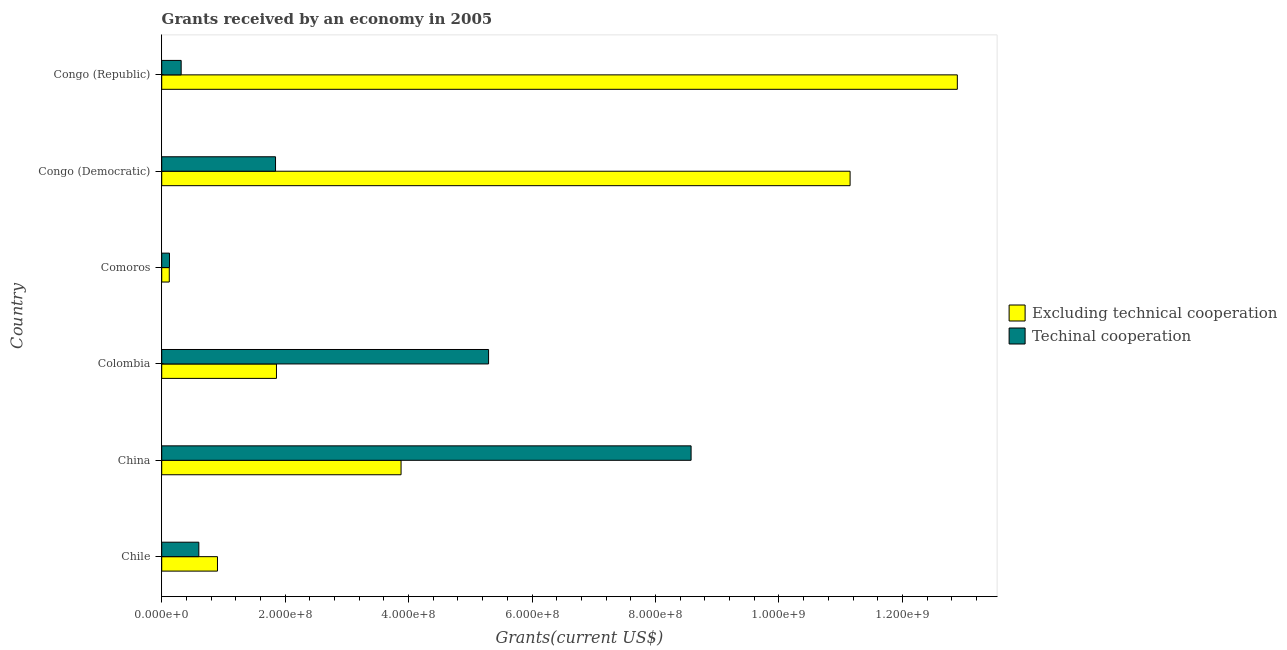How many different coloured bars are there?
Your answer should be very brief. 2. How many groups of bars are there?
Your answer should be very brief. 6. Are the number of bars per tick equal to the number of legend labels?
Your answer should be very brief. Yes. What is the label of the 6th group of bars from the top?
Your answer should be very brief. Chile. In how many cases, is the number of bars for a given country not equal to the number of legend labels?
Provide a short and direct response. 0. What is the amount of grants received(excluding technical cooperation) in Congo (Democratic)?
Your response must be concise. 1.12e+09. Across all countries, what is the maximum amount of grants received(including technical cooperation)?
Provide a short and direct response. 8.58e+08. Across all countries, what is the minimum amount of grants received(including technical cooperation)?
Provide a succinct answer. 1.26e+07. In which country was the amount of grants received(excluding technical cooperation) maximum?
Your response must be concise. Congo (Republic). In which country was the amount of grants received(including technical cooperation) minimum?
Make the answer very short. Comoros. What is the total amount of grants received(including technical cooperation) in the graph?
Make the answer very short. 1.68e+09. What is the difference between the amount of grants received(excluding technical cooperation) in China and that in Colombia?
Your answer should be very brief. 2.02e+08. What is the difference between the amount of grants received(including technical cooperation) in China and the amount of grants received(excluding technical cooperation) in Congo (Democratic)?
Give a very brief answer. -2.58e+08. What is the average amount of grants received(including technical cooperation) per country?
Give a very brief answer. 2.79e+08. What is the difference between the amount of grants received(including technical cooperation) and amount of grants received(excluding technical cooperation) in Comoros?
Your response must be concise. 3.30e+05. In how many countries, is the amount of grants received(excluding technical cooperation) greater than 560000000 US$?
Offer a very short reply. 2. What is the ratio of the amount of grants received(including technical cooperation) in China to that in Comoros?
Your answer should be compact. 68.07. Is the amount of grants received(excluding technical cooperation) in Chile less than that in Colombia?
Your answer should be very brief. Yes. What is the difference between the highest and the second highest amount of grants received(excluding technical cooperation)?
Provide a short and direct response. 1.74e+08. What is the difference between the highest and the lowest amount of grants received(including technical cooperation)?
Give a very brief answer. 8.45e+08. In how many countries, is the amount of grants received(excluding technical cooperation) greater than the average amount of grants received(excluding technical cooperation) taken over all countries?
Make the answer very short. 2. What does the 2nd bar from the top in Congo (Democratic) represents?
Give a very brief answer. Excluding technical cooperation. What does the 1st bar from the bottom in Colombia represents?
Offer a terse response. Excluding technical cooperation. Are all the bars in the graph horizontal?
Make the answer very short. Yes. How many countries are there in the graph?
Your response must be concise. 6. What is the difference between two consecutive major ticks on the X-axis?
Provide a short and direct response. 2.00e+08. How many legend labels are there?
Provide a short and direct response. 2. What is the title of the graph?
Your answer should be very brief. Grants received by an economy in 2005. Does "Urban" appear as one of the legend labels in the graph?
Keep it short and to the point. No. What is the label or title of the X-axis?
Your answer should be compact. Grants(current US$). What is the label or title of the Y-axis?
Offer a very short reply. Country. What is the Grants(current US$) in Excluding technical cooperation in Chile?
Your answer should be very brief. 9.03e+07. What is the Grants(current US$) in Techinal cooperation in Chile?
Provide a succinct answer. 6.01e+07. What is the Grants(current US$) in Excluding technical cooperation in China?
Provide a succinct answer. 3.88e+08. What is the Grants(current US$) of Techinal cooperation in China?
Your response must be concise. 8.58e+08. What is the Grants(current US$) in Excluding technical cooperation in Colombia?
Offer a terse response. 1.86e+08. What is the Grants(current US$) in Techinal cooperation in Colombia?
Your response must be concise. 5.30e+08. What is the Grants(current US$) in Excluding technical cooperation in Comoros?
Your answer should be very brief. 1.23e+07. What is the Grants(current US$) in Techinal cooperation in Comoros?
Provide a succinct answer. 1.26e+07. What is the Grants(current US$) of Excluding technical cooperation in Congo (Democratic)?
Give a very brief answer. 1.12e+09. What is the Grants(current US$) in Techinal cooperation in Congo (Democratic)?
Your answer should be compact. 1.84e+08. What is the Grants(current US$) of Excluding technical cooperation in Congo (Republic)?
Offer a very short reply. 1.29e+09. What is the Grants(current US$) in Techinal cooperation in Congo (Republic)?
Provide a short and direct response. 3.15e+07. Across all countries, what is the maximum Grants(current US$) of Excluding technical cooperation?
Offer a very short reply. 1.29e+09. Across all countries, what is the maximum Grants(current US$) of Techinal cooperation?
Ensure brevity in your answer.  8.58e+08. Across all countries, what is the minimum Grants(current US$) of Excluding technical cooperation?
Offer a very short reply. 1.23e+07. Across all countries, what is the minimum Grants(current US$) in Techinal cooperation?
Offer a very short reply. 1.26e+07. What is the total Grants(current US$) in Excluding technical cooperation in the graph?
Give a very brief answer. 3.08e+09. What is the total Grants(current US$) of Techinal cooperation in the graph?
Provide a succinct answer. 1.68e+09. What is the difference between the Grants(current US$) in Excluding technical cooperation in Chile and that in China?
Make the answer very short. -2.97e+08. What is the difference between the Grants(current US$) of Techinal cooperation in Chile and that in China?
Keep it short and to the point. -7.98e+08. What is the difference between the Grants(current US$) of Excluding technical cooperation in Chile and that in Colombia?
Your answer should be very brief. -9.56e+07. What is the difference between the Grants(current US$) of Techinal cooperation in Chile and that in Colombia?
Make the answer very short. -4.69e+08. What is the difference between the Grants(current US$) of Excluding technical cooperation in Chile and that in Comoros?
Provide a short and direct response. 7.81e+07. What is the difference between the Grants(current US$) of Techinal cooperation in Chile and that in Comoros?
Make the answer very short. 4.75e+07. What is the difference between the Grants(current US$) of Excluding technical cooperation in Chile and that in Congo (Democratic)?
Your answer should be compact. -1.02e+09. What is the difference between the Grants(current US$) of Techinal cooperation in Chile and that in Congo (Democratic)?
Ensure brevity in your answer.  -1.24e+08. What is the difference between the Grants(current US$) in Excluding technical cooperation in Chile and that in Congo (Republic)?
Ensure brevity in your answer.  -1.20e+09. What is the difference between the Grants(current US$) of Techinal cooperation in Chile and that in Congo (Republic)?
Give a very brief answer. 2.86e+07. What is the difference between the Grants(current US$) of Excluding technical cooperation in China and that in Colombia?
Give a very brief answer. 2.02e+08. What is the difference between the Grants(current US$) in Techinal cooperation in China and that in Colombia?
Make the answer very short. 3.28e+08. What is the difference between the Grants(current US$) of Excluding technical cooperation in China and that in Comoros?
Keep it short and to the point. 3.76e+08. What is the difference between the Grants(current US$) of Techinal cooperation in China and that in Comoros?
Give a very brief answer. 8.45e+08. What is the difference between the Grants(current US$) of Excluding technical cooperation in China and that in Congo (Democratic)?
Keep it short and to the point. -7.27e+08. What is the difference between the Grants(current US$) of Techinal cooperation in China and that in Congo (Democratic)?
Give a very brief answer. 6.73e+08. What is the difference between the Grants(current US$) in Excluding technical cooperation in China and that in Congo (Republic)?
Provide a succinct answer. -9.01e+08. What is the difference between the Grants(current US$) in Techinal cooperation in China and that in Congo (Republic)?
Offer a terse response. 8.26e+08. What is the difference between the Grants(current US$) in Excluding technical cooperation in Colombia and that in Comoros?
Your answer should be compact. 1.74e+08. What is the difference between the Grants(current US$) in Techinal cooperation in Colombia and that in Comoros?
Provide a succinct answer. 5.17e+08. What is the difference between the Grants(current US$) of Excluding technical cooperation in Colombia and that in Congo (Democratic)?
Keep it short and to the point. -9.29e+08. What is the difference between the Grants(current US$) of Techinal cooperation in Colombia and that in Congo (Democratic)?
Give a very brief answer. 3.45e+08. What is the difference between the Grants(current US$) in Excluding technical cooperation in Colombia and that in Congo (Republic)?
Your answer should be very brief. -1.10e+09. What is the difference between the Grants(current US$) in Techinal cooperation in Colombia and that in Congo (Republic)?
Give a very brief answer. 4.98e+08. What is the difference between the Grants(current US$) of Excluding technical cooperation in Comoros and that in Congo (Democratic)?
Your answer should be very brief. -1.10e+09. What is the difference between the Grants(current US$) in Techinal cooperation in Comoros and that in Congo (Democratic)?
Your response must be concise. -1.72e+08. What is the difference between the Grants(current US$) of Excluding technical cooperation in Comoros and that in Congo (Republic)?
Provide a short and direct response. -1.28e+09. What is the difference between the Grants(current US$) of Techinal cooperation in Comoros and that in Congo (Republic)?
Offer a terse response. -1.89e+07. What is the difference between the Grants(current US$) of Excluding technical cooperation in Congo (Democratic) and that in Congo (Republic)?
Give a very brief answer. -1.74e+08. What is the difference between the Grants(current US$) of Techinal cooperation in Congo (Democratic) and that in Congo (Republic)?
Offer a very short reply. 1.53e+08. What is the difference between the Grants(current US$) of Excluding technical cooperation in Chile and the Grants(current US$) of Techinal cooperation in China?
Your answer should be compact. -7.67e+08. What is the difference between the Grants(current US$) of Excluding technical cooperation in Chile and the Grants(current US$) of Techinal cooperation in Colombia?
Your answer should be compact. -4.39e+08. What is the difference between the Grants(current US$) of Excluding technical cooperation in Chile and the Grants(current US$) of Techinal cooperation in Comoros?
Your answer should be compact. 7.77e+07. What is the difference between the Grants(current US$) in Excluding technical cooperation in Chile and the Grants(current US$) in Techinal cooperation in Congo (Democratic)?
Ensure brevity in your answer.  -9.41e+07. What is the difference between the Grants(current US$) of Excluding technical cooperation in Chile and the Grants(current US$) of Techinal cooperation in Congo (Republic)?
Your response must be concise. 5.88e+07. What is the difference between the Grants(current US$) of Excluding technical cooperation in China and the Grants(current US$) of Techinal cooperation in Colombia?
Ensure brevity in your answer.  -1.42e+08. What is the difference between the Grants(current US$) of Excluding technical cooperation in China and the Grants(current US$) of Techinal cooperation in Comoros?
Offer a terse response. 3.75e+08. What is the difference between the Grants(current US$) of Excluding technical cooperation in China and the Grants(current US$) of Techinal cooperation in Congo (Democratic)?
Your answer should be compact. 2.03e+08. What is the difference between the Grants(current US$) in Excluding technical cooperation in China and the Grants(current US$) in Techinal cooperation in Congo (Republic)?
Your answer should be very brief. 3.56e+08. What is the difference between the Grants(current US$) of Excluding technical cooperation in Colombia and the Grants(current US$) of Techinal cooperation in Comoros?
Give a very brief answer. 1.73e+08. What is the difference between the Grants(current US$) of Excluding technical cooperation in Colombia and the Grants(current US$) of Techinal cooperation in Congo (Democratic)?
Keep it short and to the point. 1.52e+06. What is the difference between the Grants(current US$) in Excluding technical cooperation in Colombia and the Grants(current US$) in Techinal cooperation in Congo (Republic)?
Make the answer very short. 1.54e+08. What is the difference between the Grants(current US$) of Excluding technical cooperation in Comoros and the Grants(current US$) of Techinal cooperation in Congo (Democratic)?
Make the answer very short. -1.72e+08. What is the difference between the Grants(current US$) of Excluding technical cooperation in Comoros and the Grants(current US$) of Techinal cooperation in Congo (Republic)?
Your answer should be compact. -1.92e+07. What is the difference between the Grants(current US$) in Excluding technical cooperation in Congo (Democratic) and the Grants(current US$) in Techinal cooperation in Congo (Republic)?
Ensure brevity in your answer.  1.08e+09. What is the average Grants(current US$) of Excluding technical cooperation per country?
Give a very brief answer. 5.13e+08. What is the average Grants(current US$) in Techinal cooperation per country?
Offer a very short reply. 2.79e+08. What is the difference between the Grants(current US$) in Excluding technical cooperation and Grants(current US$) in Techinal cooperation in Chile?
Keep it short and to the point. 3.02e+07. What is the difference between the Grants(current US$) in Excluding technical cooperation and Grants(current US$) in Techinal cooperation in China?
Keep it short and to the point. -4.70e+08. What is the difference between the Grants(current US$) of Excluding technical cooperation and Grants(current US$) of Techinal cooperation in Colombia?
Your answer should be compact. -3.44e+08. What is the difference between the Grants(current US$) of Excluding technical cooperation and Grants(current US$) of Techinal cooperation in Comoros?
Provide a succinct answer. -3.30e+05. What is the difference between the Grants(current US$) of Excluding technical cooperation and Grants(current US$) of Techinal cooperation in Congo (Democratic)?
Your answer should be very brief. 9.31e+08. What is the difference between the Grants(current US$) of Excluding technical cooperation and Grants(current US$) of Techinal cooperation in Congo (Republic)?
Your answer should be very brief. 1.26e+09. What is the ratio of the Grants(current US$) of Excluding technical cooperation in Chile to that in China?
Your answer should be compact. 0.23. What is the ratio of the Grants(current US$) in Techinal cooperation in Chile to that in China?
Your answer should be very brief. 0.07. What is the ratio of the Grants(current US$) of Excluding technical cooperation in Chile to that in Colombia?
Your answer should be compact. 0.49. What is the ratio of the Grants(current US$) in Techinal cooperation in Chile to that in Colombia?
Provide a succinct answer. 0.11. What is the ratio of the Grants(current US$) of Excluding technical cooperation in Chile to that in Comoros?
Give a very brief answer. 7.36. What is the ratio of the Grants(current US$) in Techinal cooperation in Chile to that in Comoros?
Your answer should be very brief. 4.77. What is the ratio of the Grants(current US$) of Excluding technical cooperation in Chile to that in Congo (Democratic)?
Make the answer very short. 0.08. What is the ratio of the Grants(current US$) in Techinal cooperation in Chile to that in Congo (Democratic)?
Provide a succinct answer. 0.33. What is the ratio of the Grants(current US$) in Excluding technical cooperation in Chile to that in Congo (Republic)?
Provide a succinct answer. 0.07. What is the ratio of the Grants(current US$) of Techinal cooperation in Chile to that in Congo (Republic)?
Provide a succinct answer. 1.91. What is the ratio of the Grants(current US$) of Excluding technical cooperation in China to that in Colombia?
Keep it short and to the point. 2.09. What is the ratio of the Grants(current US$) in Techinal cooperation in China to that in Colombia?
Provide a succinct answer. 1.62. What is the ratio of the Grants(current US$) in Excluding technical cooperation in China to that in Comoros?
Offer a very short reply. 31.6. What is the ratio of the Grants(current US$) of Techinal cooperation in China to that in Comoros?
Your answer should be very brief. 68.07. What is the ratio of the Grants(current US$) in Excluding technical cooperation in China to that in Congo (Democratic)?
Provide a short and direct response. 0.35. What is the ratio of the Grants(current US$) in Techinal cooperation in China to that in Congo (Democratic)?
Keep it short and to the point. 4.65. What is the ratio of the Grants(current US$) in Excluding technical cooperation in China to that in Congo (Republic)?
Your answer should be very brief. 0.3. What is the ratio of the Grants(current US$) in Techinal cooperation in China to that in Congo (Republic)?
Your answer should be very brief. 27.21. What is the ratio of the Grants(current US$) of Excluding technical cooperation in Colombia to that in Comoros?
Your response must be concise. 15.15. What is the ratio of the Grants(current US$) of Techinal cooperation in Colombia to that in Comoros?
Provide a short and direct response. 42.03. What is the ratio of the Grants(current US$) in Techinal cooperation in Colombia to that in Congo (Democratic)?
Provide a succinct answer. 2.87. What is the ratio of the Grants(current US$) of Excluding technical cooperation in Colombia to that in Congo (Republic)?
Keep it short and to the point. 0.14. What is the ratio of the Grants(current US$) in Techinal cooperation in Colombia to that in Congo (Republic)?
Your answer should be very brief. 16.8. What is the ratio of the Grants(current US$) of Excluding technical cooperation in Comoros to that in Congo (Democratic)?
Ensure brevity in your answer.  0.01. What is the ratio of the Grants(current US$) of Techinal cooperation in Comoros to that in Congo (Democratic)?
Your response must be concise. 0.07. What is the ratio of the Grants(current US$) in Excluding technical cooperation in Comoros to that in Congo (Republic)?
Give a very brief answer. 0.01. What is the ratio of the Grants(current US$) in Techinal cooperation in Comoros to that in Congo (Republic)?
Keep it short and to the point. 0.4. What is the ratio of the Grants(current US$) in Excluding technical cooperation in Congo (Democratic) to that in Congo (Republic)?
Provide a succinct answer. 0.87. What is the ratio of the Grants(current US$) in Techinal cooperation in Congo (Democratic) to that in Congo (Republic)?
Your answer should be compact. 5.85. What is the difference between the highest and the second highest Grants(current US$) in Excluding technical cooperation?
Provide a succinct answer. 1.74e+08. What is the difference between the highest and the second highest Grants(current US$) in Techinal cooperation?
Your answer should be very brief. 3.28e+08. What is the difference between the highest and the lowest Grants(current US$) in Excluding technical cooperation?
Your answer should be very brief. 1.28e+09. What is the difference between the highest and the lowest Grants(current US$) in Techinal cooperation?
Make the answer very short. 8.45e+08. 